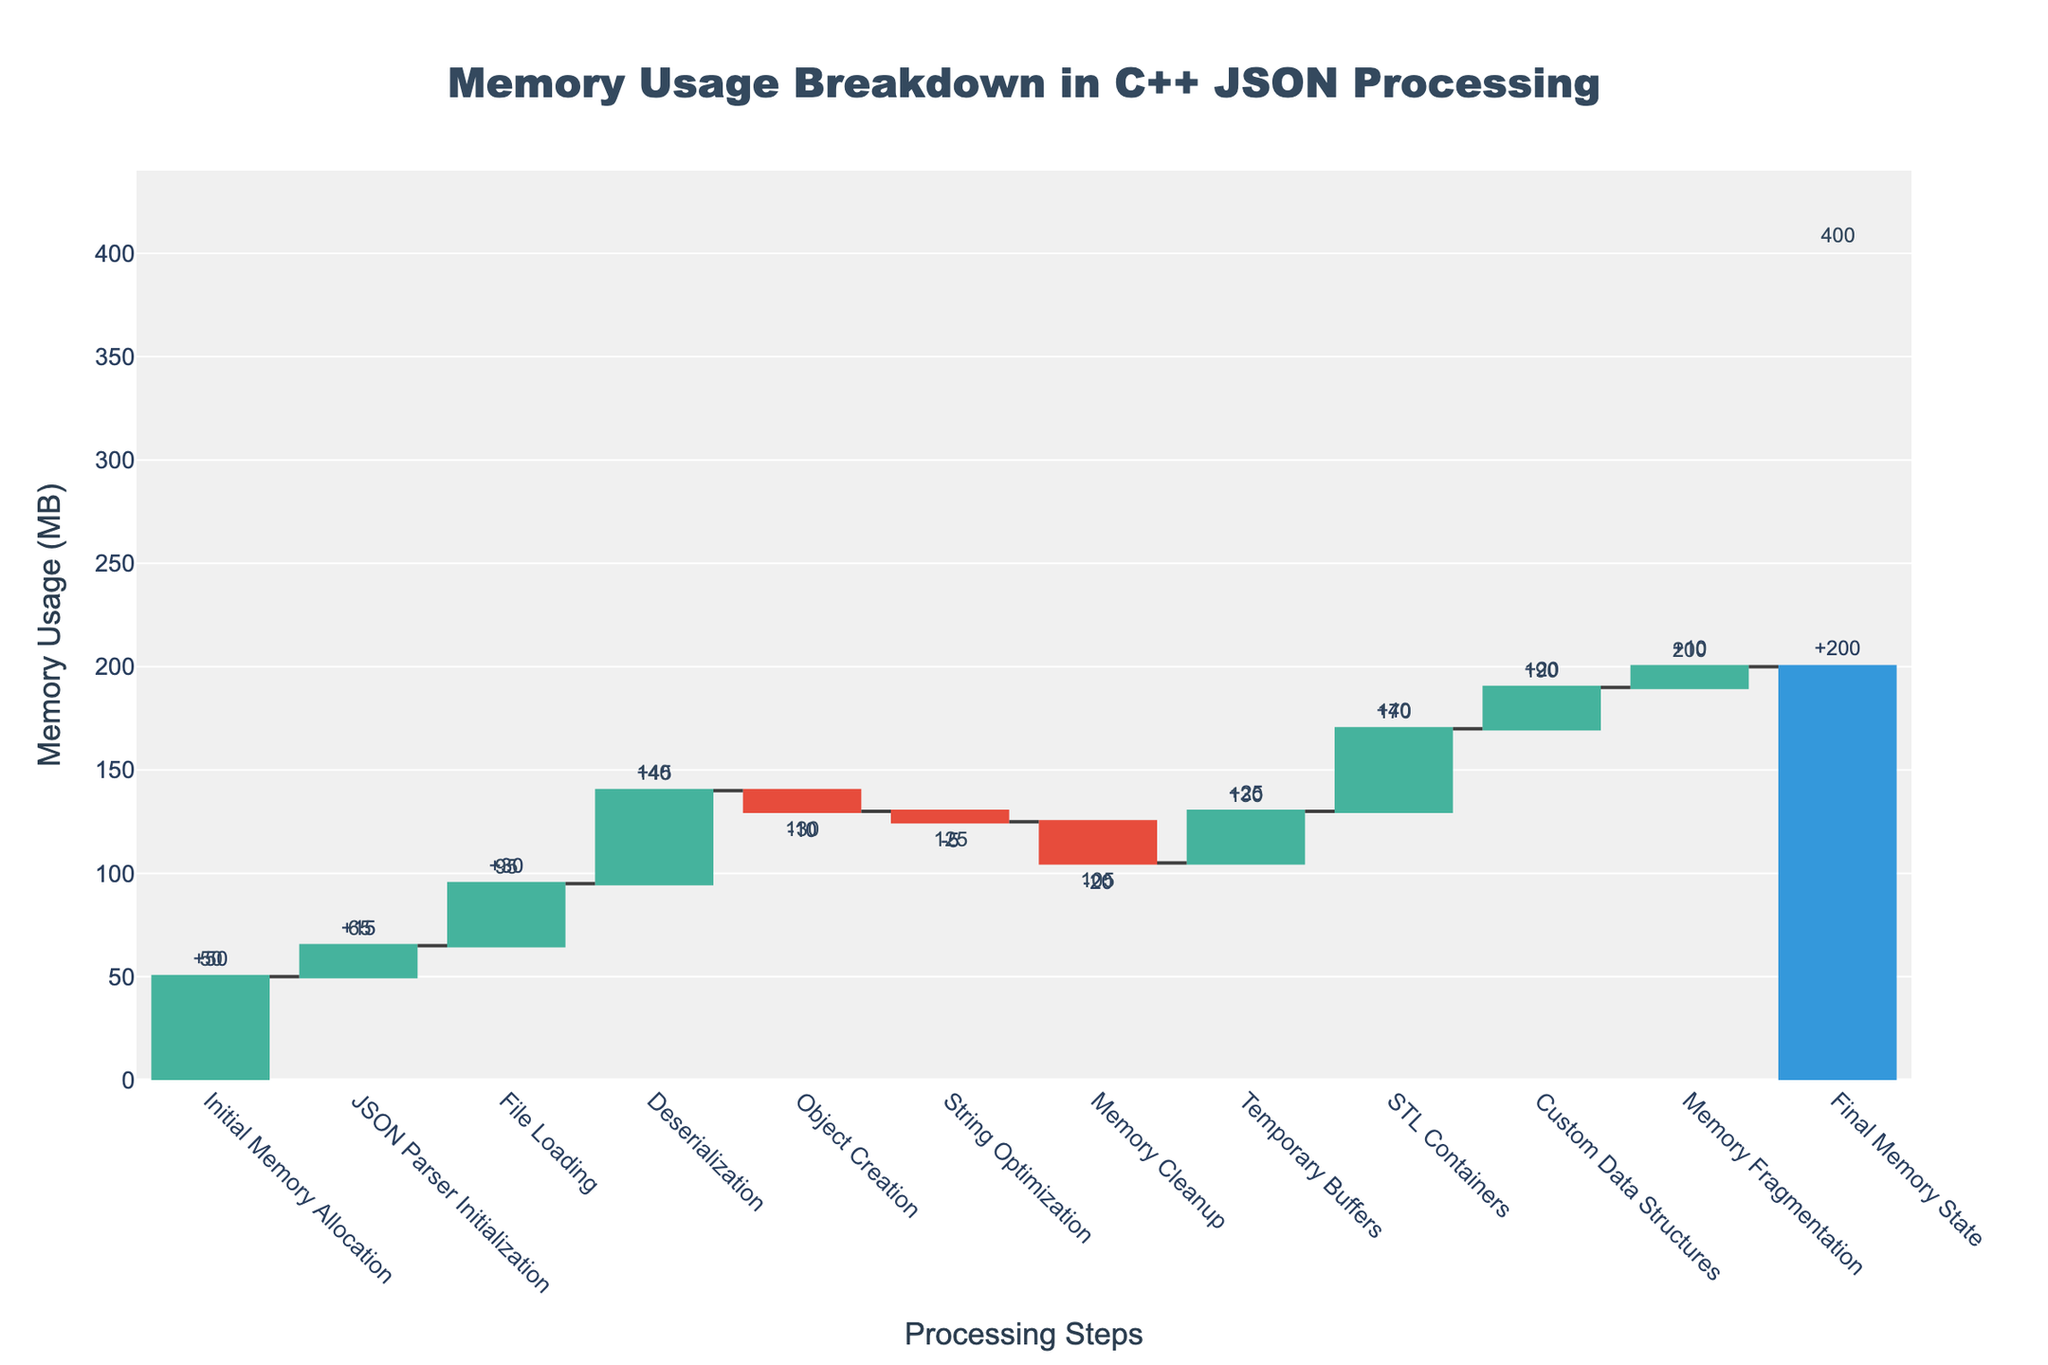What is the title of the waterfall chart? The title is displayed at the top center of the chart.
Answer: Memory Usage Breakdown in C++ JSON Processing What is the value associated with the Initial Memory Allocation category? The value for this category is directly labeled on the chart.
Answer: 50 How many categories are displayed in the waterfall chart? Count the number of distinct bars/labels shown on the x-axis.
Answer: 12 How much memory is used after the File Loading step? This step accumulates memory from the previous steps. The cumulative value at "File Loading" is the sum of "Initial Memory Allocation" and "JSON Parser Initialization" plus "File Loading" = 50 + 15 + 30.
Answer: 95 What is the net effect of String Optimization on memory usage? String Optimization is a negative value, indicating a memory release or optimization.
Answer: -5 What is the final memory usage of the application? This value is the total cumulative sum indicated at the end of the waterfall chart.
Answer: 200 Which step incurs the largest positive memory allocation? Compare the positive values and identify the highest. The largest positive value is associated with Deserialization.
Answer: 45 By how much does memory usage increase from Temporary Buffers compared to Custom Data Structures? Subtract the memory increase for Custom Data Structures from that for Temporary Buffers (25 - 20).
Answer: 5 Which steps result in a net reduction of memory usage? Identify steps with negative values. In this chart, these steps are Object Creation, String Optimization, and Memory Cleanup.
Answer: Object Creation, String Optimization, and Memory Cleanup What is the cumulative memory usage just before Memory Fragmentation? Add up all values up to but excluding Memory Fragmentation: 50 + 15 + 30 + 45 - 10 - 5 - 20 + 25 + 40 + 20 = 190.
Answer: 190 